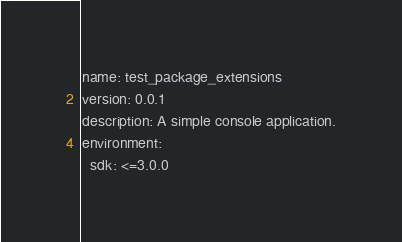Convert code to text. <code><loc_0><loc_0><loc_500><loc_500><_YAML_>name: test_package_extensions
version: 0.0.1
description: A simple console application.
environment:
  sdk: <=3.0.0
</code> 